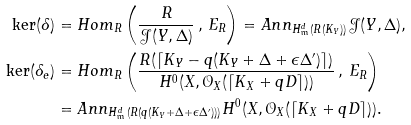Convert formula to latex. <formula><loc_0><loc_0><loc_500><loc_500>\ker ( \delta ) & = H o m _ { R } \left ( \frac { R } { \mathcal { J } ( Y , \Delta ) } \, , \, E _ { R } \right ) = A n n _ { H _ { \mathfrak { m } } ^ { d } ( R ( K _ { Y } ) ) } \mathcal { J } ( Y , \Delta ) , \\ \ker ( \delta _ { e } ) & = H o m _ { R } \left ( \frac { R ( \lceil K _ { Y } - q ( K _ { Y } + \Delta + \epsilon \Delta ^ { \prime } ) \rceil ) } { H ^ { 0 } ( X , \mathcal { O } _ { X } ( \lceil K _ { X } + q D \rceil ) ) } \, , \, E _ { R } \right ) \\ & = A n n _ { H _ { \mathfrak { m } } ^ { d } ( R ( q ( K _ { Y } + \Delta + \epsilon \Delta ^ { \prime } ) ) ) } H ^ { 0 } ( X , \mathcal { O } _ { X } ( \lceil K _ { X } + q D \rceil ) ) .</formula> 